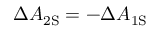Convert formula to latex. <formula><loc_0><loc_0><loc_500><loc_500>\Delta A _ { 2 S } = - \Delta A _ { 1 S }</formula> 